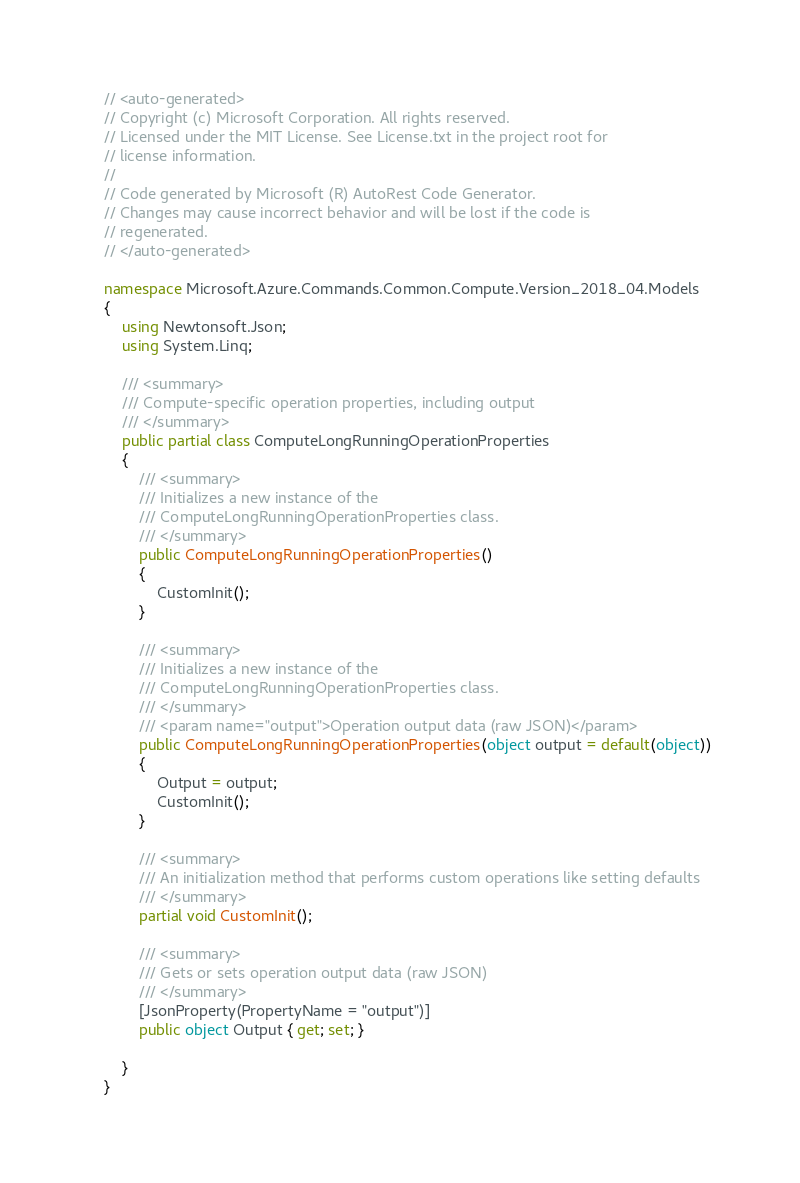<code> <loc_0><loc_0><loc_500><loc_500><_C#_>// <auto-generated>
// Copyright (c) Microsoft Corporation. All rights reserved.
// Licensed under the MIT License. See License.txt in the project root for
// license information.
//
// Code generated by Microsoft (R) AutoRest Code Generator.
// Changes may cause incorrect behavior and will be lost if the code is
// regenerated.
// </auto-generated>

namespace Microsoft.Azure.Commands.Common.Compute.Version_2018_04.Models
{
    using Newtonsoft.Json;
    using System.Linq;

    /// <summary>
    /// Compute-specific operation properties, including output
    /// </summary>
    public partial class ComputeLongRunningOperationProperties
    {
        /// <summary>
        /// Initializes a new instance of the
        /// ComputeLongRunningOperationProperties class.
        /// </summary>
        public ComputeLongRunningOperationProperties()
        {
            CustomInit();
        }

        /// <summary>
        /// Initializes a new instance of the
        /// ComputeLongRunningOperationProperties class.
        /// </summary>
        /// <param name="output">Operation output data (raw JSON)</param>
        public ComputeLongRunningOperationProperties(object output = default(object))
        {
            Output = output;
            CustomInit();
        }

        /// <summary>
        /// An initialization method that performs custom operations like setting defaults
        /// </summary>
        partial void CustomInit();

        /// <summary>
        /// Gets or sets operation output data (raw JSON)
        /// </summary>
        [JsonProperty(PropertyName = "output")]
        public object Output { get; set; }

    }
}
</code> 